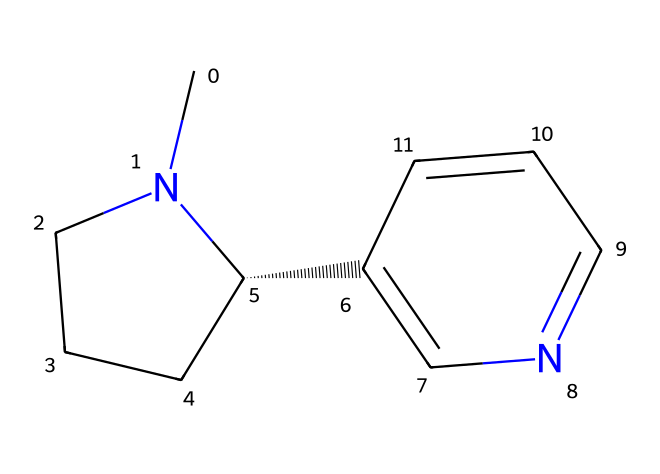What is the molecular formula of nicotine? To find the molecular formula, count all carbon (C), hydrogen (H), and nitrogen (N) atoms in the SMILES representation. There are 10 carbons, 14 hydrogens, and 2 nitrogens, resulting in C10H14N2.
Answer: C10H14N2 How many rings are present in the structure of nicotine? Inspect the structure in the SMILES representation, noting the cyclic portions indicated. There are two main cycles in the structure, confirming that two rings are present.
Answer: 2 What type of nitrogen atom is present in nicotine? Examine the nitrogen atoms in the SMILES representation. One nitrogen is in a cyclic structure (pyridine-like), while another is part of a piperidine ring. This implies the presence of a tertiary nitrogen.
Answer: tertiary Which specific type of alkaloid is nicotine classified as? Based on the structural features of nicotine, such as its nitrogen arrangement and biological effects, nicotine is classified as a pyridine alkaloid due to its pyridine-like ring.
Answer: pyridine Does nicotine have a polar or nonpolar character? Assess the overall structure and functional groups of nicotine. The presence of nitrogen atoms and their ability to engage in hydrogen bonding suggest a polar character for nicotine.
Answer: polar What is the primary biological effect of nicotine? Understanding nicotine's known effects on the body, it primarily acts as a stimulant, affecting the central nervous system by enhancing neurotransmitter release.
Answer: stimulant 